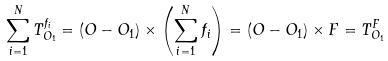Convert formula to latex. <formula><loc_0><loc_0><loc_500><loc_500>\sum _ { i = 1 } ^ { N } T _ { O _ { 1 } } ^ { f _ { i } } = ( O - O _ { 1 } ) \times \left ( \sum _ { i = 1 } ^ { N } f _ { i } \right ) = ( O - O _ { 1 } ) \times F = T _ { O _ { 1 } } ^ { F }</formula> 